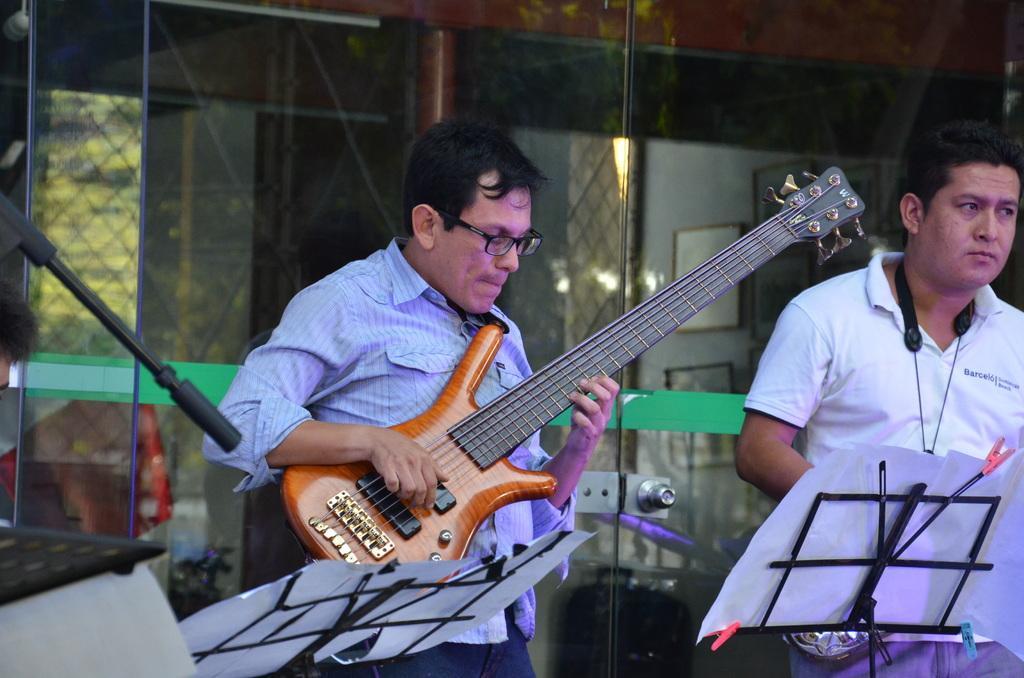In one or two sentences, can you explain what this image depicts? there are two persons in which one person is playing guitar 